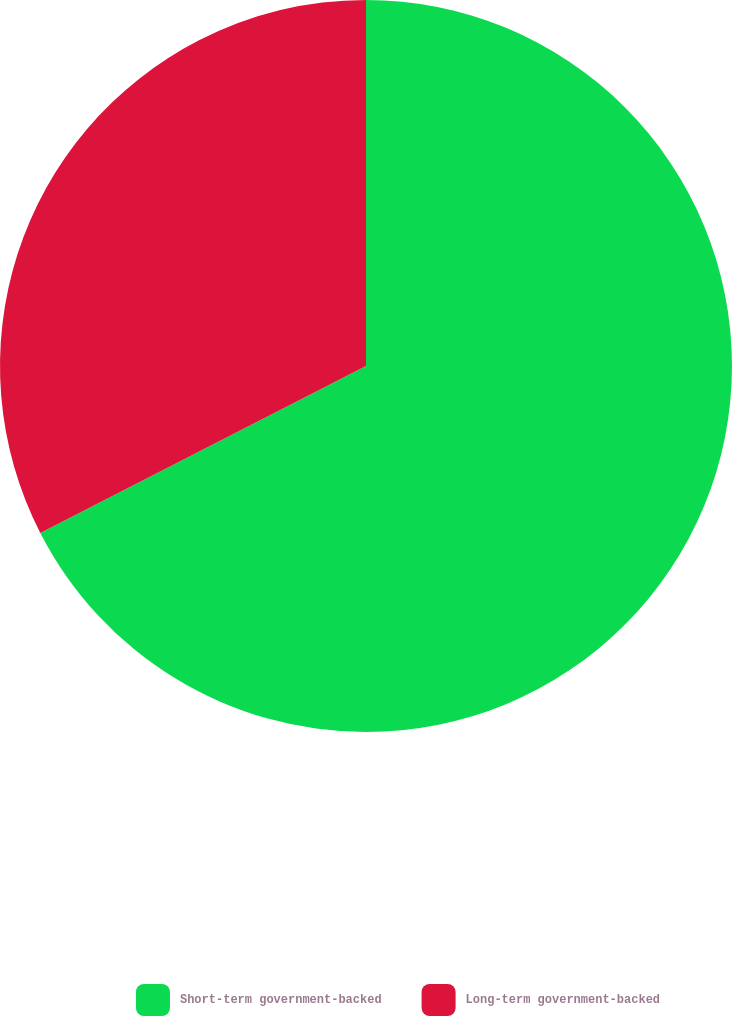Convert chart. <chart><loc_0><loc_0><loc_500><loc_500><pie_chart><fcel>Short-term government-backed<fcel>Long-term government-backed<nl><fcel>67.46%<fcel>32.54%<nl></chart> 